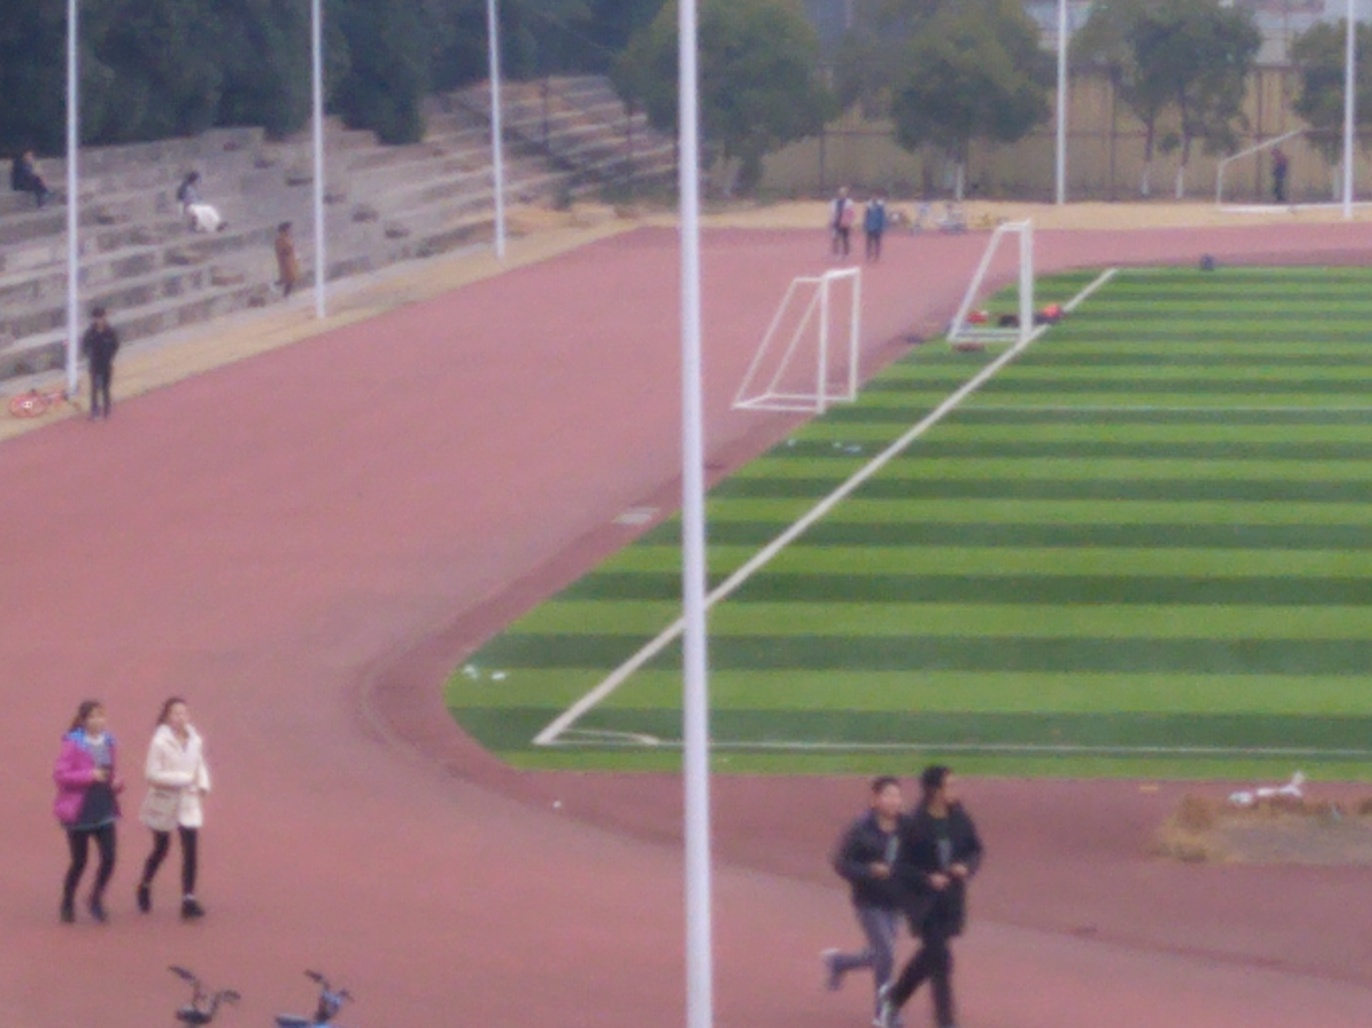What does this photo capture? This photo captures an outdoor sports facility featuring a running track and several tiers of grass-covered seating, which are commonly used for spectators during athletic events. In the background, there is a goal post for football or soccer, hinting at a multipurpose use of the field. 